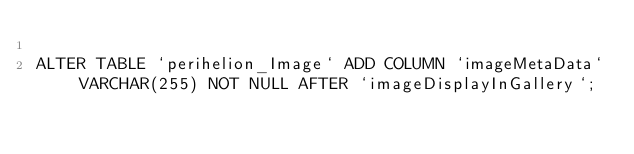<code> <loc_0><loc_0><loc_500><loc_500><_SQL_>
ALTER TABLE `perihelion_Image` ADD COLUMN `imageMetaData` VARCHAR(255) NOT NULL AFTER `imageDisplayInGallery`;
</code> 